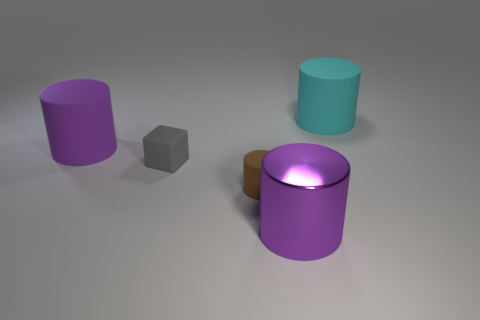What material is the purple cylinder left of the large thing that is in front of the big purple cylinder that is left of the purple metal cylinder?
Make the answer very short. Rubber. Is the number of gray blocks that are in front of the large cyan object greater than the number of small rubber cylinders in front of the tiny matte cylinder?
Offer a terse response. Yes. How many other big things have the same material as the cyan object?
Offer a terse response. 1. Does the big purple object on the right side of the tiny block have the same shape as the matte thing that is left of the small gray object?
Keep it short and to the point. Yes. What is the color of the large thing on the left side of the tiny gray matte object?
Your answer should be compact. Purple. Are there any big rubber things that have the same shape as the purple shiny thing?
Offer a terse response. Yes. What material is the large cyan object?
Ensure brevity in your answer.  Rubber. How big is the rubber thing that is both in front of the big purple matte object and to the right of the cube?
Offer a very short reply. Small. There is a large cylinder that is the same color as the large metal object; what is it made of?
Keep it short and to the point. Rubber. What number of purple cylinders are there?
Give a very brief answer. 2. 